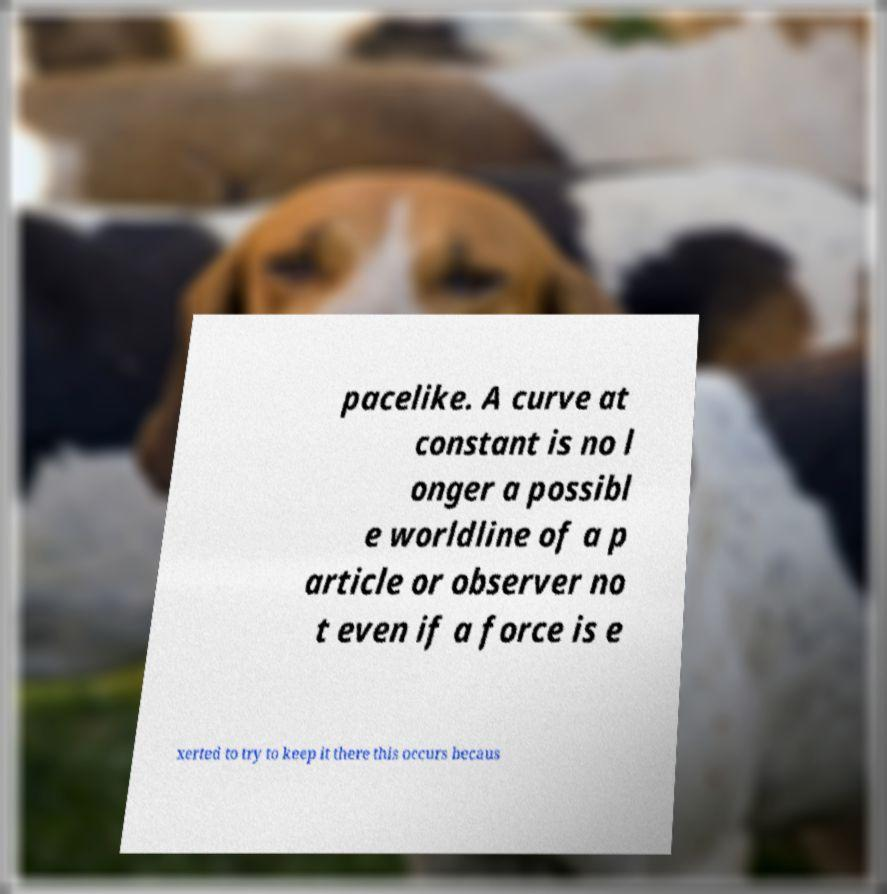Can you read and provide the text displayed in the image?This photo seems to have some interesting text. Can you extract and type it out for me? pacelike. A curve at constant is no l onger a possibl e worldline of a p article or observer no t even if a force is e xerted to try to keep it there this occurs becaus 